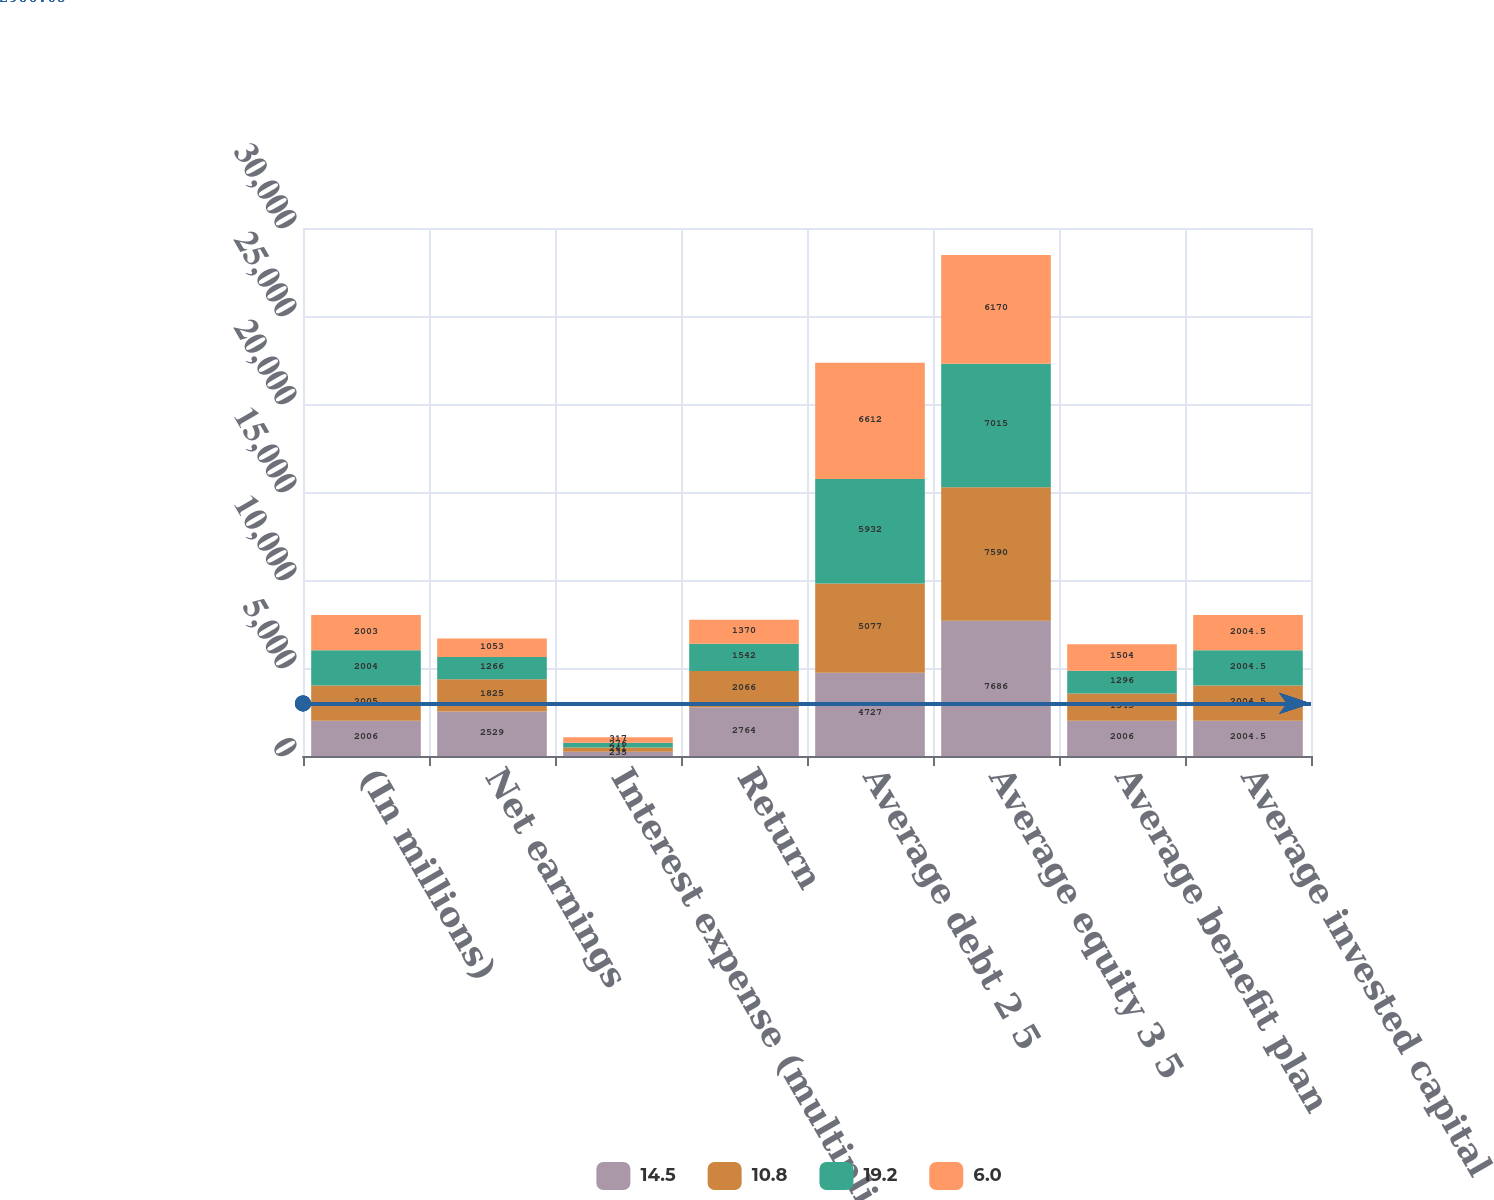<chart> <loc_0><loc_0><loc_500><loc_500><stacked_bar_chart><ecel><fcel>(In millions)<fcel>Net earnings<fcel>Interest expense (multiplied<fcel>Return<fcel>Average debt 2 5<fcel>Average equity 3 5<fcel>Average benefit plan<fcel>Average invested capital<nl><fcel>14.5<fcel>2006<fcel>2529<fcel>235<fcel>2764<fcel>4727<fcel>7686<fcel>2006<fcel>2004.5<nl><fcel>10.8<fcel>2005<fcel>1825<fcel>241<fcel>2066<fcel>5077<fcel>7590<fcel>1545<fcel>2004.5<nl><fcel>19.2<fcel>2004<fcel>1266<fcel>276<fcel>1542<fcel>5932<fcel>7015<fcel>1296<fcel>2004.5<nl><fcel>6<fcel>2003<fcel>1053<fcel>317<fcel>1370<fcel>6612<fcel>6170<fcel>1504<fcel>2004.5<nl></chart> 